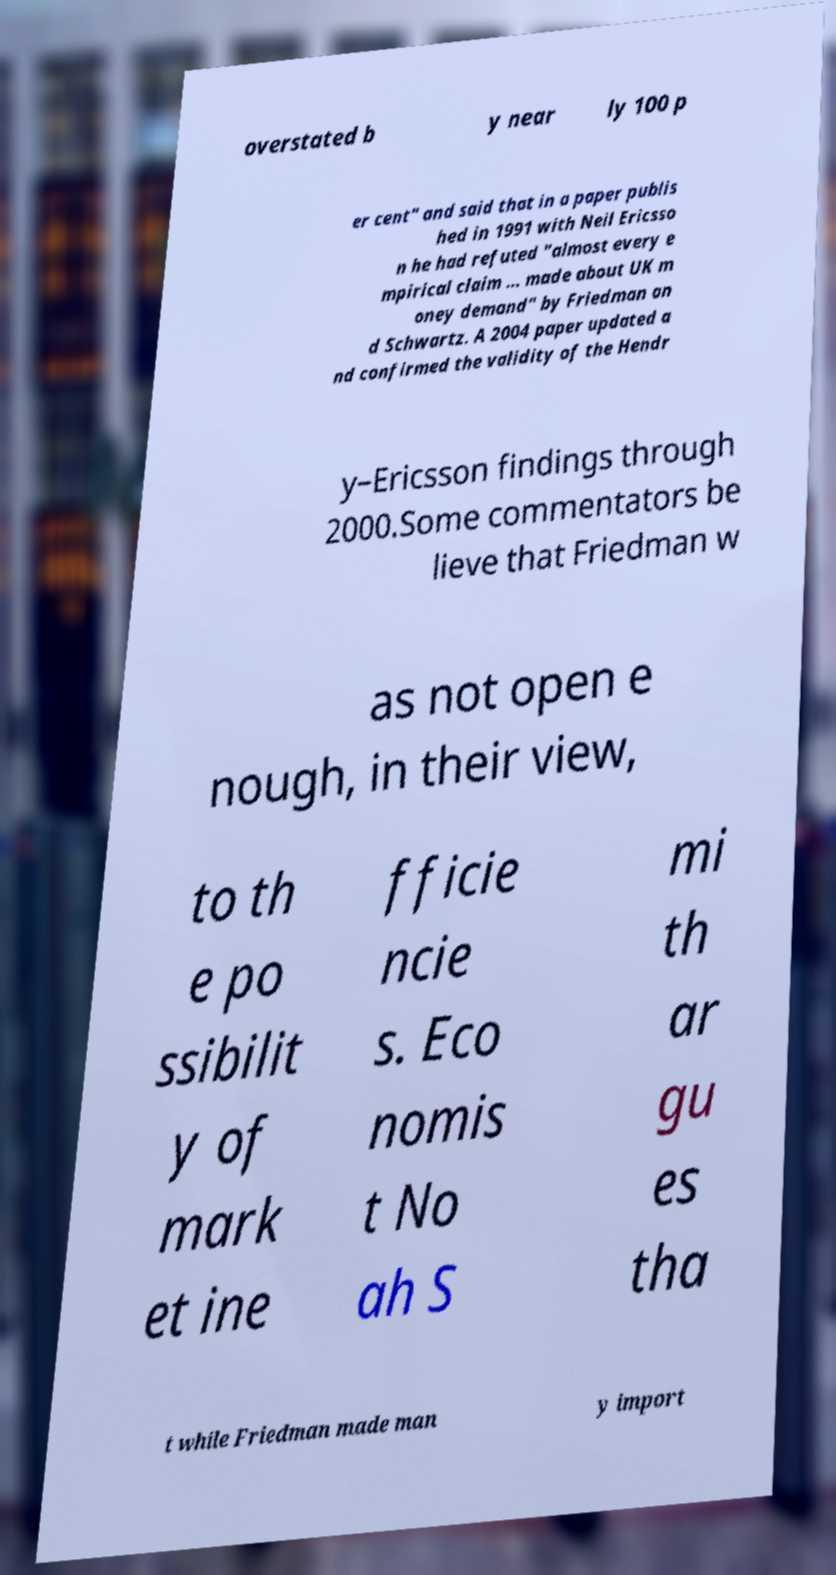There's text embedded in this image that I need extracted. Can you transcribe it verbatim? overstated b y near ly 100 p er cent" and said that in a paper publis hed in 1991 with Neil Ericsso n he had refuted "almost every e mpirical claim ... made about UK m oney demand" by Friedman an d Schwartz. A 2004 paper updated a nd confirmed the validity of the Hendr y–Ericsson findings through 2000.Some commentators be lieve that Friedman w as not open e nough, in their view, to th e po ssibilit y of mark et ine fficie ncie s. Eco nomis t No ah S mi th ar gu es tha t while Friedman made man y import 